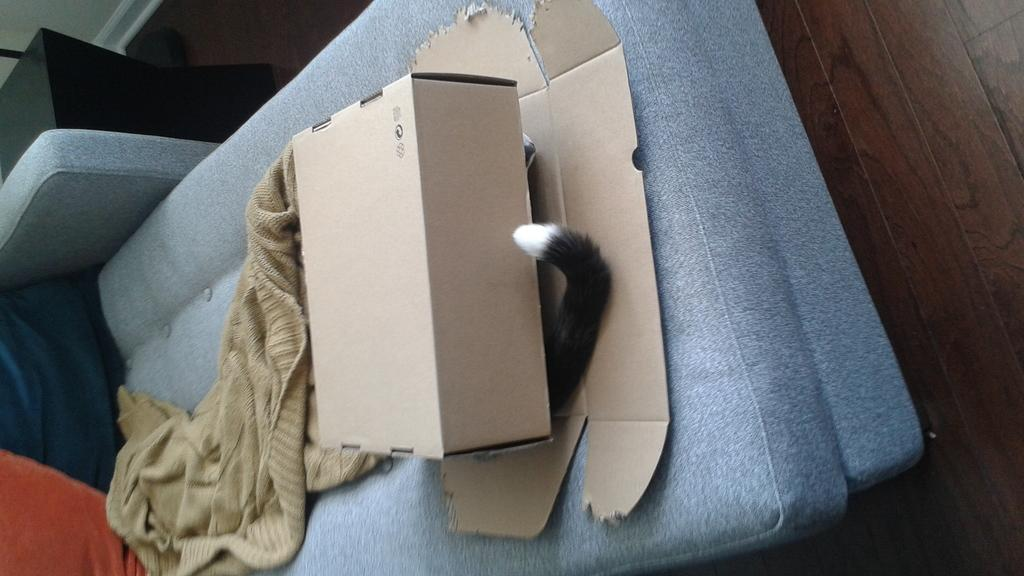What is the main object in the image? There is a cardboard box in the image. Can you describe any specific details about the cardboard box? There is a tail in black and white color in the image, which might be related to the cardboard box. What other items can be seen in the image? There is a towel and objects on a blue color couch in the image. Can you tell me how many cameras are visible in the image? There are no cameras present in the image. Is there a zoo in the background of the image? There is no mention of a zoo or any background in the provided facts, so it cannot be determined from the image. 